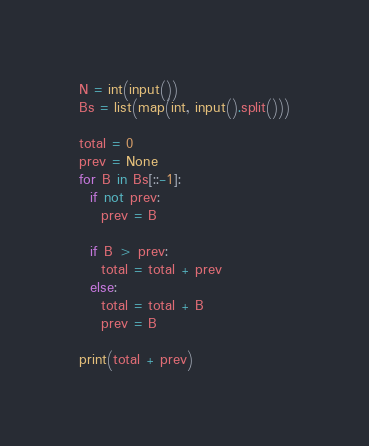Convert code to text. <code><loc_0><loc_0><loc_500><loc_500><_Python_>N = int(input())
Bs = list(map(int, input().split()))

total = 0
prev = None
for B in Bs[::-1]:
  if not prev:
    prev = B
  
  if B > prev:
    total = total + prev
  else:
    total = total + B
    prev = B

print(total + prev)</code> 